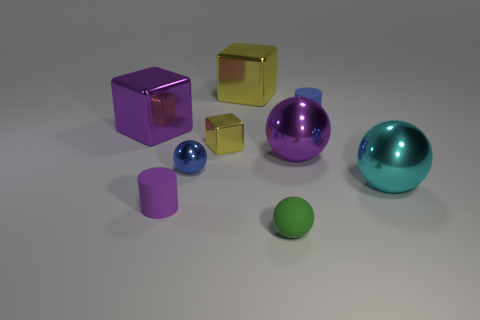What is the size of the purple shiny thing that is the same shape as the small blue metallic thing?
Your response must be concise. Large. Is there anything else that is the same size as the green sphere?
Provide a succinct answer. Yes. There is a tiny cylinder behind the large cyan object; what color is it?
Offer a very short reply. Blue. There is a cylinder that is left of the yellow object that is behind the yellow cube in front of the blue matte cylinder; what is its material?
Give a very brief answer. Rubber. What size is the metal ball that is to the left of the tiny metallic object that is behind the purple ball?
Offer a terse response. Small. There is a rubber thing that is the same shape as the cyan shiny object; what color is it?
Give a very brief answer. Green. How many small matte cylinders have the same color as the small metallic block?
Provide a short and direct response. 0. Does the purple ball have the same size as the cyan metallic thing?
Your answer should be compact. Yes. What is the material of the big purple block?
Make the answer very short. Metal. The other cylinder that is made of the same material as the tiny purple cylinder is what color?
Make the answer very short. Blue. 